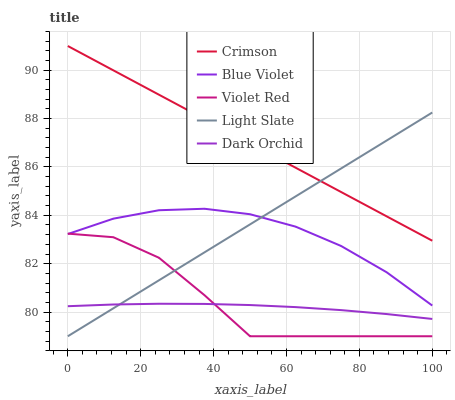Does Dark Orchid have the minimum area under the curve?
Answer yes or no. Yes. Does Crimson have the maximum area under the curve?
Answer yes or no. Yes. Does Light Slate have the minimum area under the curve?
Answer yes or no. No. Does Light Slate have the maximum area under the curve?
Answer yes or no. No. Is Light Slate the smoothest?
Answer yes or no. Yes. Is Violet Red the roughest?
Answer yes or no. Yes. Is Violet Red the smoothest?
Answer yes or no. No. Is Light Slate the roughest?
Answer yes or no. No. Does Light Slate have the lowest value?
Answer yes or no. Yes. Does Dark Orchid have the lowest value?
Answer yes or no. No. Does Crimson have the highest value?
Answer yes or no. Yes. Does Light Slate have the highest value?
Answer yes or no. No. Is Dark Orchid less than Crimson?
Answer yes or no. Yes. Is Blue Violet greater than Dark Orchid?
Answer yes or no. Yes. Does Light Slate intersect Violet Red?
Answer yes or no. Yes. Is Light Slate less than Violet Red?
Answer yes or no. No. Is Light Slate greater than Violet Red?
Answer yes or no. No. Does Dark Orchid intersect Crimson?
Answer yes or no. No. 